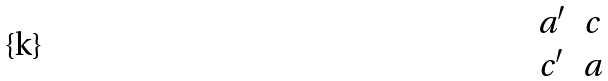<formula> <loc_0><loc_0><loc_500><loc_500>\begin{matrix} a ^ { \prime } & c \\ c ^ { \prime } & a \end{matrix}</formula> 